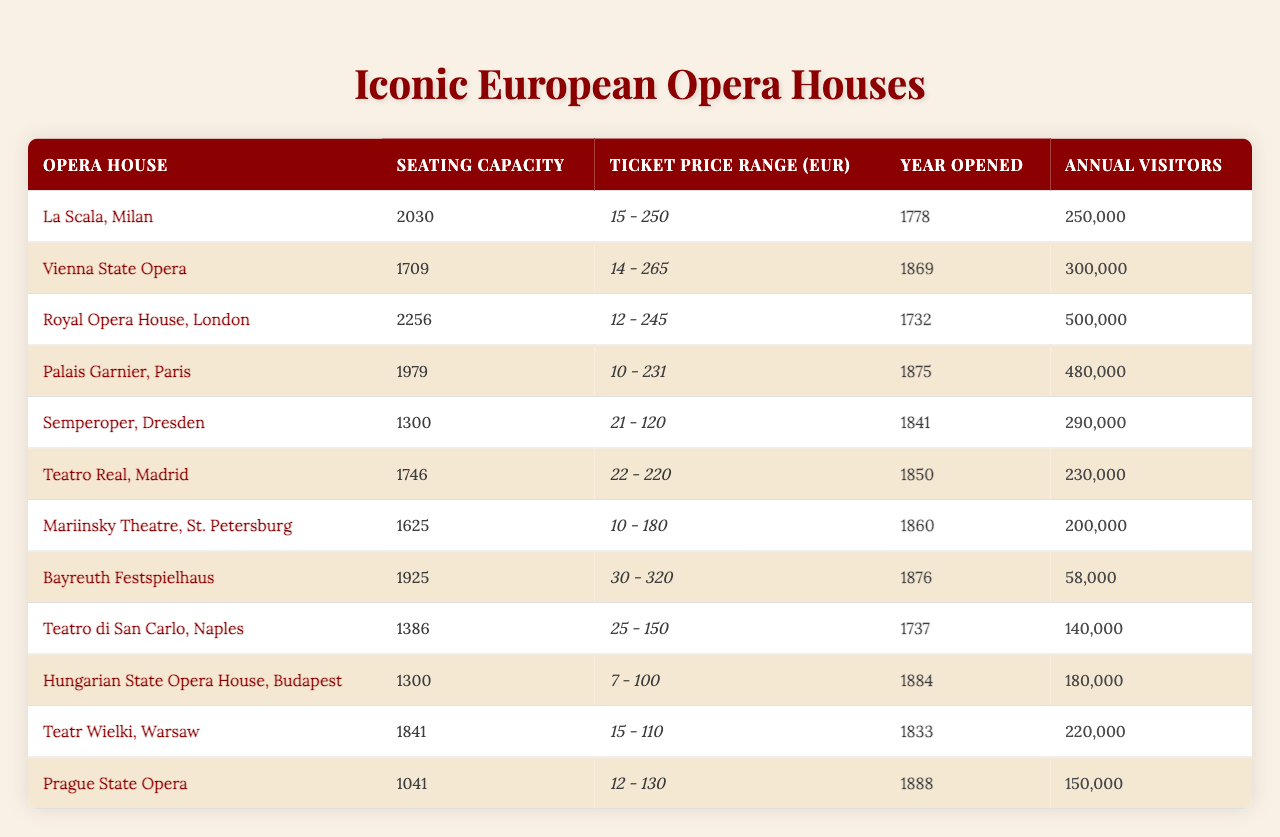What is the seating capacity of the Royal Opera House in London? In the table under the "Seating Capacity" column, the row for the Royal Opera House, London shows a capacity of 2256.
Answer: 2256 Which opera house has the highest ticket price range? To find this, we look at the "Highest Ticket Price" column. The Bayreuth Festspielhaus has the highest price at 320 EUR.
Answer: Bayreuth Festspielhaus What is the lowest ticket price for the Vienna State Opera? Check the "Lowest Ticket Price (EUR)" column for the Vienna State Opera's row, which lists the lowest price as 14 EUR.
Answer: 14 EUR Which opera house opened most recently? Looking at the "Year Opened" column, the latest year is 1888, corresponding to the Prague State Opera.
Answer: Prague State Opera What is the average seating capacity of the opera houses listed? Adding the seating capacities (2030 + 1709 + 2256 + 1979 + 1300 + 1746 + 1625 + 1925 + 1386 + 1300 + 1841 + 1041) gives a total of 22,052. Dividing by the number of opera houses (12) yields an average seating capacity of 1837.67.
Answer: 1837.67 Is the lowest ticket price for the Teatro Real in Madrid higher than 20 EUR? The lowest ticket price listed for the Teatro Real is 22 EUR, which is indeed higher than 20 EUR.
Answer: Yes How many annual visitors does the Palais Garnier, Paris have compared to La Scala, Milan? The Palais Garnier has 480,000 annual visitors, while La Scala has 250,000. The difference is 480,000 - 250,000 = 230,000 more visitors for Palais Garnier.
Answer: 230,000 Which opera house has the most annual visitors, and how many? The table shows that the Royal Opera House, London has the most annual visitors at 500,000.
Answer: Royal Opera House, London with 500,000 visitors What is the range of ticket prices for the Hungarian State Opera House in Budapest? The lowest ticket price is 7 EUR and the highest is 100 EUR; this means the range is from 7 to 100 EUR.
Answer: 7 - 100 EUR How does the seating capacity of the Semperoper, Dresden compare to Teatro di San Carlo, Naples? The Semperoper has a seating capacity of 1300, while the Teatro di San Carlo has a seating capacity of 1386, which is 86 more.
Answer: 86 more Which opera house has an annual visitor count closest to 200,000? The Mariinsky Theatre in St. Petersburg has an annual visitor count of 200,000, which matches this specification exactly.
Answer: Mariinsky Theatre 